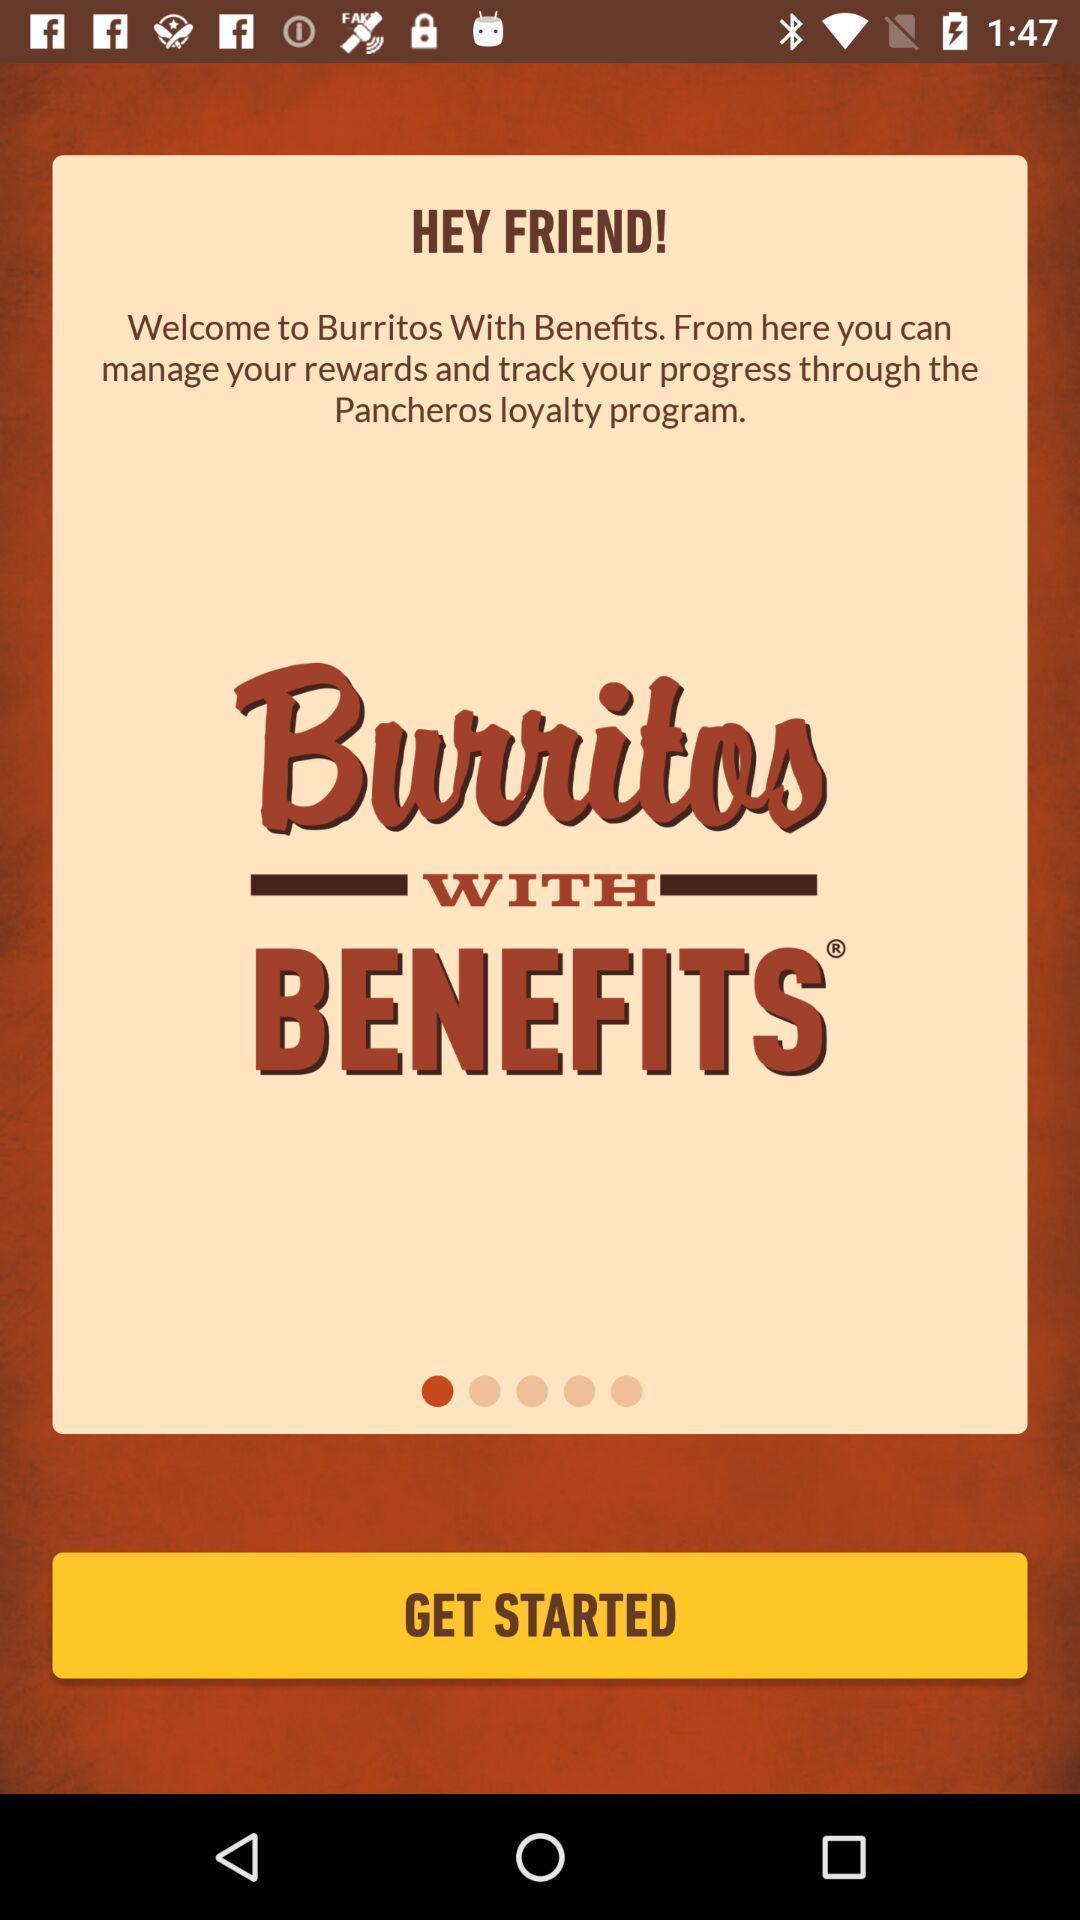Explain what's happening in this screen capture. Welcome page of the application to manage your rewards. 